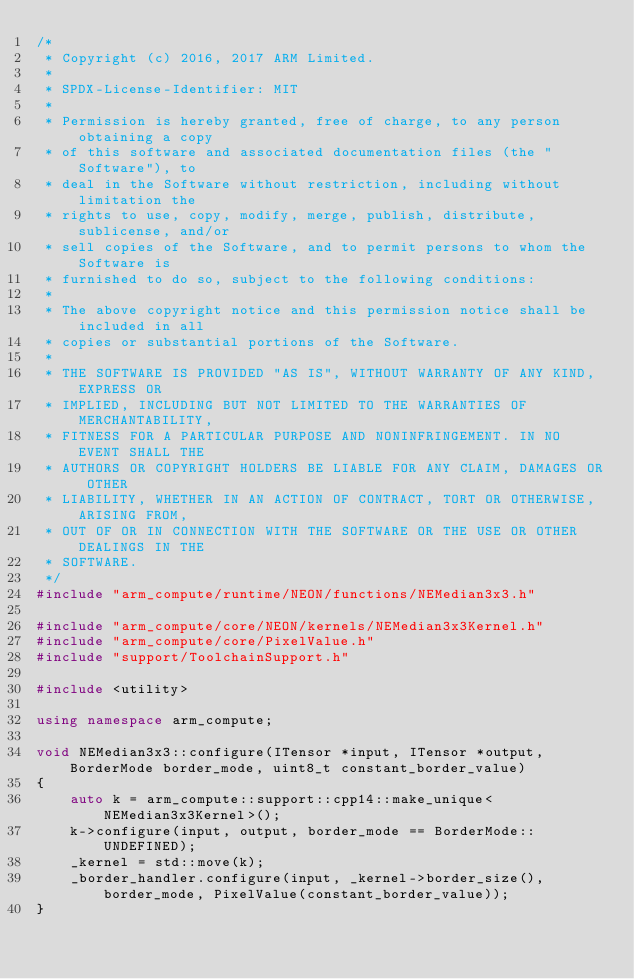Convert code to text. <code><loc_0><loc_0><loc_500><loc_500><_C++_>/*
 * Copyright (c) 2016, 2017 ARM Limited.
 *
 * SPDX-License-Identifier: MIT
 *
 * Permission is hereby granted, free of charge, to any person obtaining a copy
 * of this software and associated documentation files (the "Software"), to
 * deal in the Software without restriction, including without limitation the
 * rights to use, copy, modify, merge, publish, distribute, sublicense, and/or
 * sell copies of the Software, and to permit persons to whom the Software is
 * furnished to do so, subject to the following conditions:
 *
 * The above copyright notice and this permission notice shall be included in all
 * copies or substantial portions of the Software.
 *
 * THE SOFTWARE IS PROVIDED "AS IS", WITHOUT WARRANTY OF ANY KIND, EXPRESS OR
 * IMPLIED, INCLUDING BUT NOT LIMITED TO THE WARRANTIES OF MERCHANTABILITY,
 * FITNESS FOR A PARTICULAR PURPOSE AND NONINFRINGEMENT. IN NO EVENT SHALL THE
 * AUTHORS OR COPYRIGHT HOLDERS BE LIABLE FOR ANY CLAIM, DAMAGES OR OTHER
 * LIABILITY, WHETHER IN AN ACTION OF CONTRACT, TORT OR OTHERWISE, ARISING FROM,
 * OUT OF OR IN CONNECTION WITH THE SOFTWARE OR THE USE OR OTHER DEALINGS IN THE
 * SOFTWARE.
 */
#include "arm_compute/runtime/NEON/functions/NEMedian3x3.h"

#include "arm_compute/core/NEON/kernels/NEMedian3x3Kernel.h"
#include "arm_compute/core/PixelValue.h"
#include "support/ToolchainSupport.h"

#include <utility>

using namespace arm_compute;

void NEMedian3x3::configure(ITensor *input, ITensor *output, BorderMode border_mode, uint8_t constant_border_value)
{
    auto k = arm_compute::support::cpp14::make_unique<NEMedian3x3Kernel>();
    k->configure(input, output, border_mode == BorderMode::UNDEFINED);
    _kernel = std::move(k);
    _border_handler.configure(input, _kernel->border_size(), border_mode, PixelValue(constant_border_value));
}
</code> 